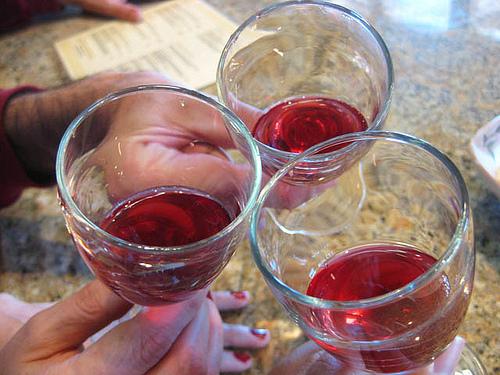What is in the glasses?
Give a very brief answer. Wine. Are her fingernails polished?
Be succinct. Yes. How many glasses are there?
Answer briefly. 3. 